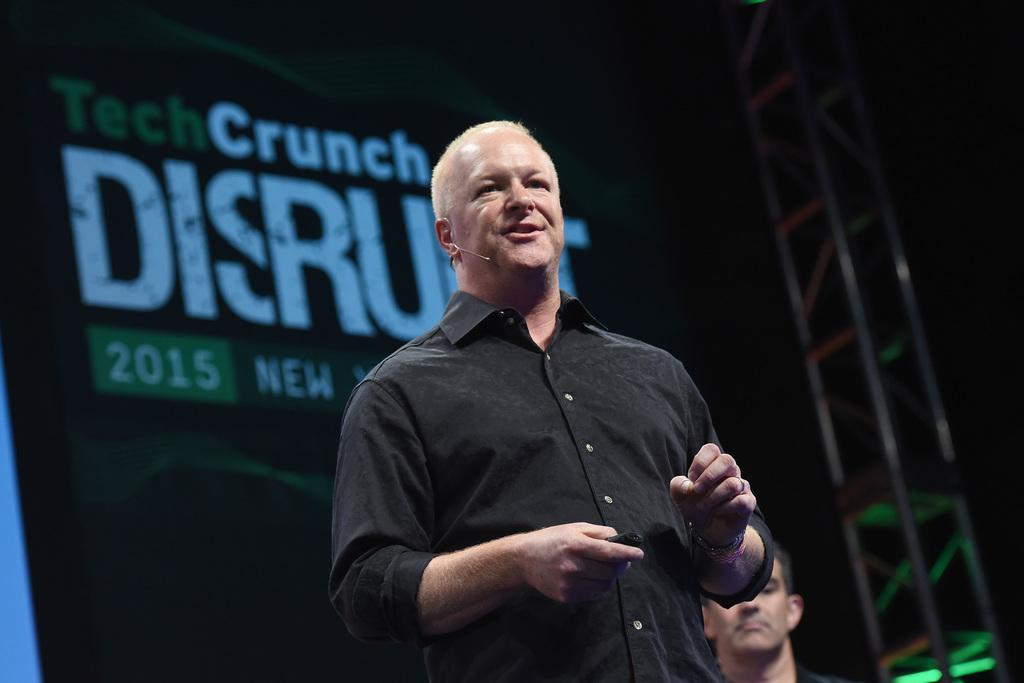What is the person in the image doing? The person is standing and holding a microphone. What might the person be doing with the microphone? The person is speaking, which suggests they might be using the microphone to amplify their voice. What can be seen in the background of the image? There is an advertisement hoarding visible behind the person. What type of design is featured on the alarm clock in the image? There is no alarm clock present in the image. 